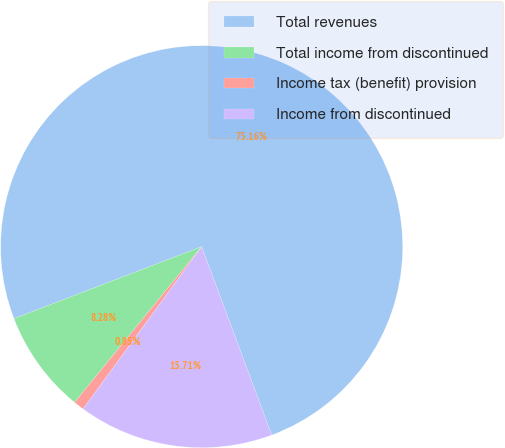Convert chart to OTSL. <chart><loc_0><loc_0><loc_500><loc_500><pie_chart><fcel>Total revenues<fcel>Total income from discontinued<fcel>Income tax (benefit) provision<fcel>Income from discontinued<nl><fcel>75.17%<fcel>8.28%<fcel>0.85%<fcel>15.71%<nl></chart> 